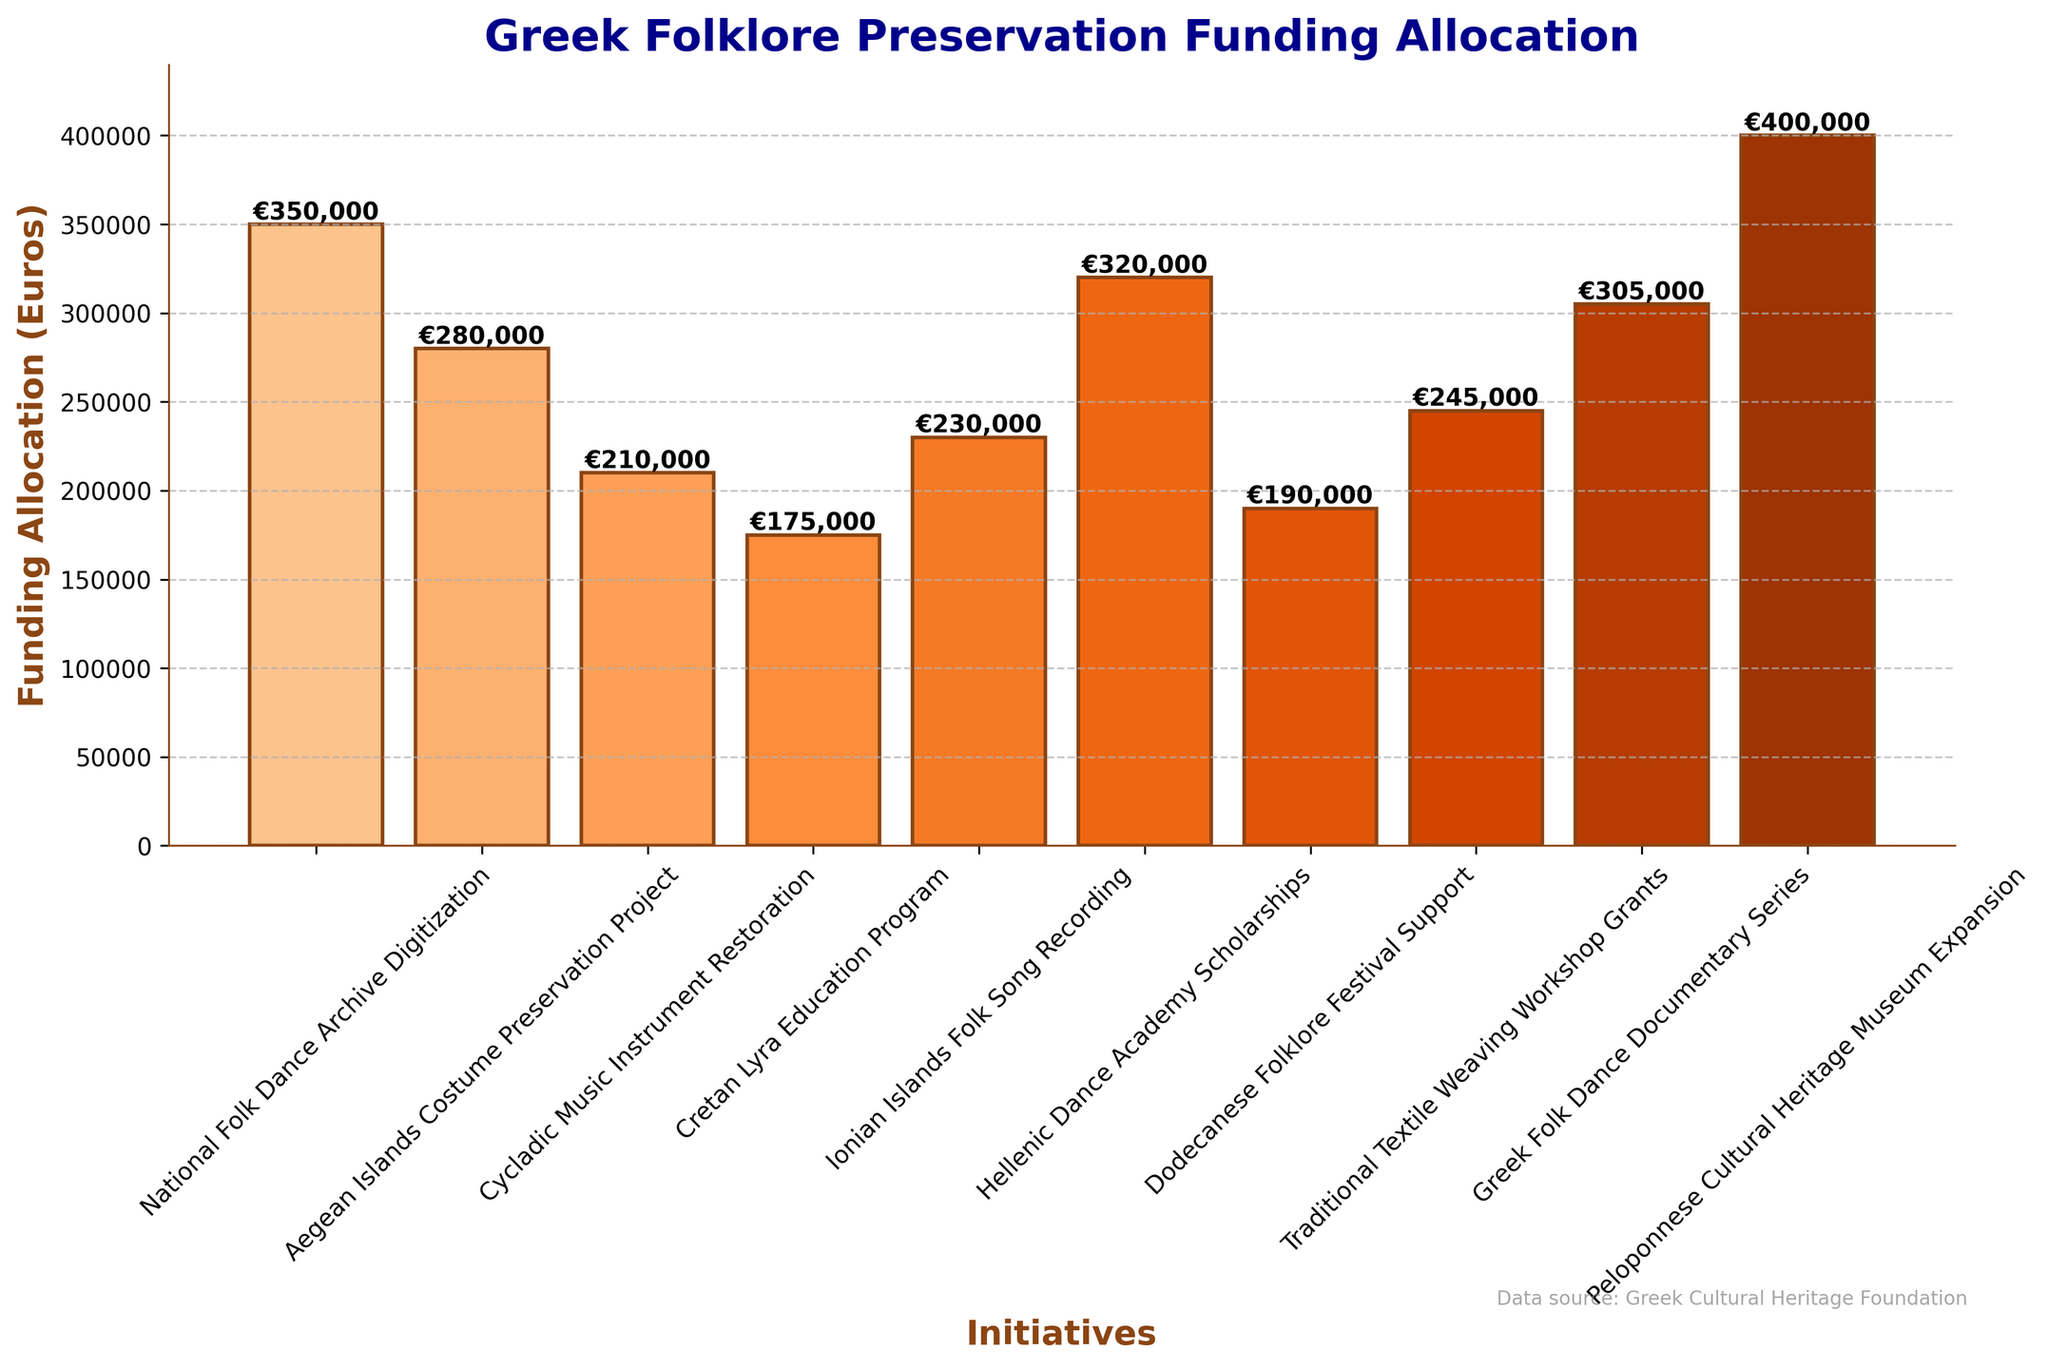What is the initiative with the highest funding allocation? Look at the height of the bars to determine which one is the tallest. Notice that the bar for "Peloponnese Cultural Heritage Museum Expansion" is the highest.
Answer: Peloponnese Cultural Heritage Museum Expansion Which initiative received more funding: Greek Folk Dance Documentary Series or Cycladic Music Instrument Restoration? Compare the heights of the bars for "Greek Folk Dance Documentary Series" and "Cycladic Music Instrument Restoration". The "Greek Folk Dance Documentary Series" bar is higher than that of "Cycladic Music Instrument Restoration".
Answer: Greek Folk Dance Documentary Series What is the difference in funding between the National Folk Dance Archive Digitization and the Dodecanese Folklore Festival Support? Subtract the funding amount for "Dodecanese Folklore Festival Support" from that of "National Folk Dance Archive Digitization" (€350,000 - €190,000).
Answer: €160,000 What are the top three initiatives in terms of funding allocation? Identify the three tallest bars, which correspond to "Peloponnese Cultural Heritage Museum Expansion", "National Folk Dance Archive Digitization", and "Hellenic Dance Academy Scholarships".
Answer: Peloponnese Cultural Heritage Museum Expansion, National Folk Dance Archive Digitization, Hellenic Dance Academy Scholarships Which initiative received the least funding? Look for the shortest bar on the plot. The bar for the "Cretan Lyra Education Program" is the shortest.
Answer: Cretan Lyra Education Program What is the total funding allocated to all initiatives? Sum up the funding amounts for all initiatives (€350,000 + €280,000 + €210,000 + €175,000 + €230,000 + €320,000 + €190,000 + €245,000 + €305,000 + €400,000).
Answer: €2,705,000 What is the median funding amount across all initiatives? First, list all funding amounts in ascending order: €175,000, €190,000, €210,000, €230,000, €245,000, €280,000, €305,000, €320,000, €350,000, €400,000. The median is the average of the 5th and 6th values: (€245,000 + €280,000)/2.
Answer: €262,500 What is the combined funding for initiatives related to dance? Sum the funding amounts for related initiatives: "National Folk Dance Archive Digitization" (€350,000), "Hellenic Dance Academy Scholarships" (€320,000), and "Greek Folk Dance Documentary Series" (€305,000).
Answer: €975,000 